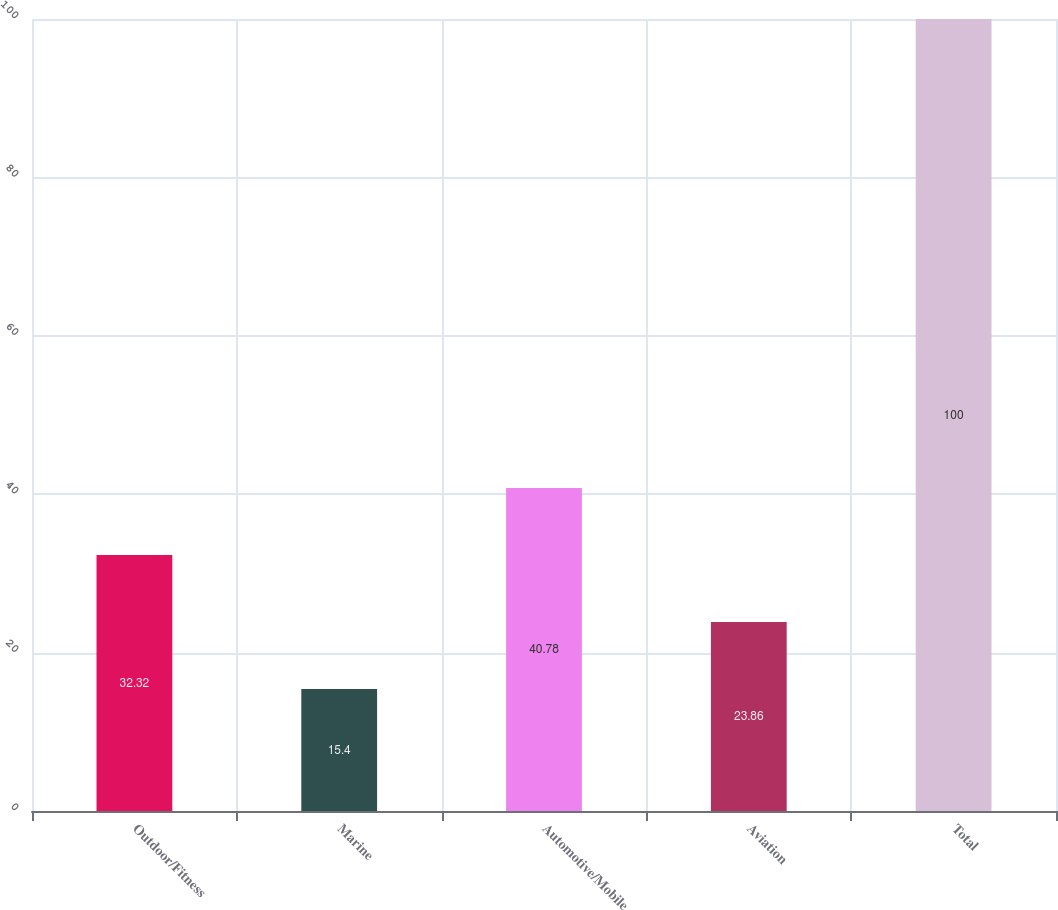Convert chart. <chart><loc_0><loc_0><loc_500><loc_500><bar_chart><fcel>Outdoor/Fitness<fcel>Marine<fcel>Automotive/Mobile<fcel>Aviation<fcel>Total<nl><fcel>32.32<fcel>15.4<fcel>40.78<fcel>23.86<fcel>100<nl></chart> 